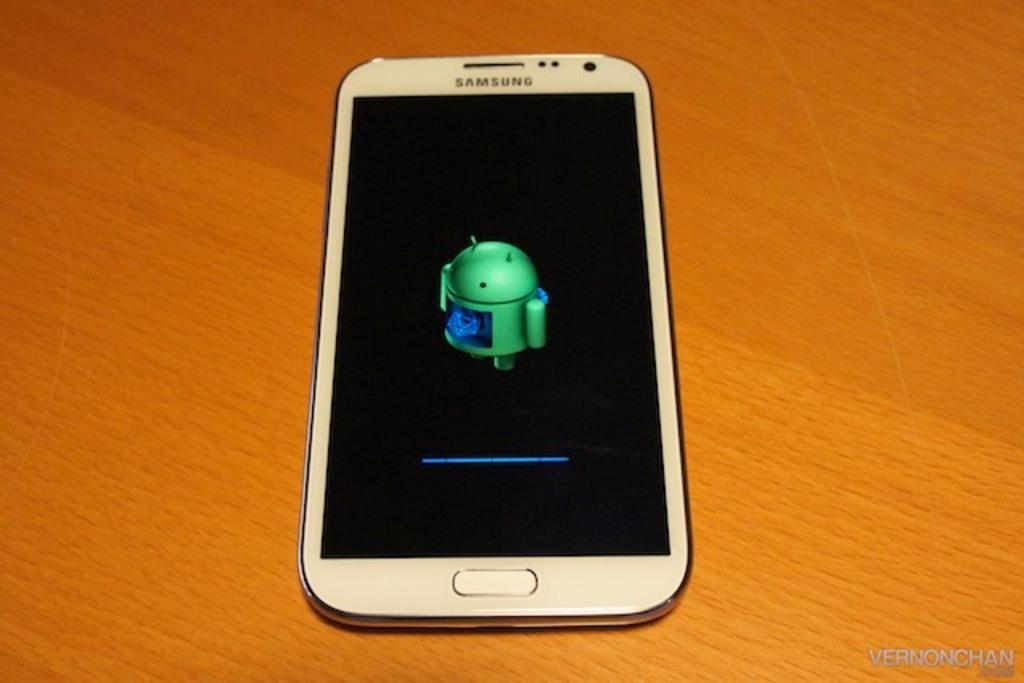Provide a one-sentence caption for the provided image. a Samsung phone that is on the table. 